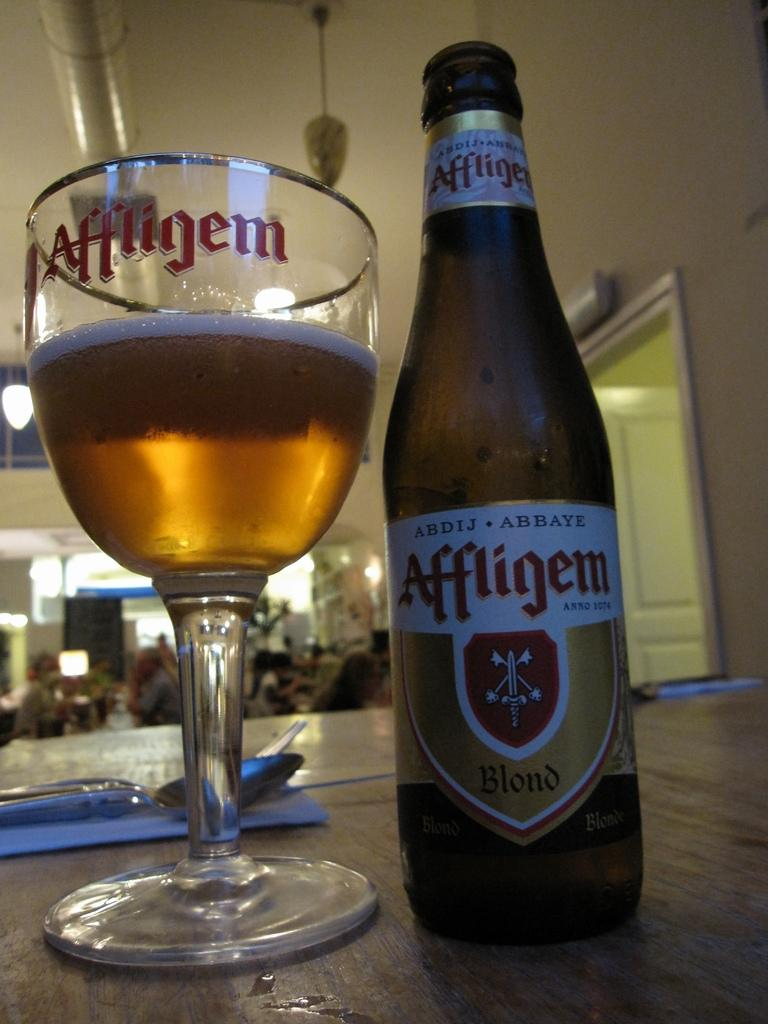<image>
Present a compact description of the photo's key features. An Affligem bottle sits next to a glass on a table. 